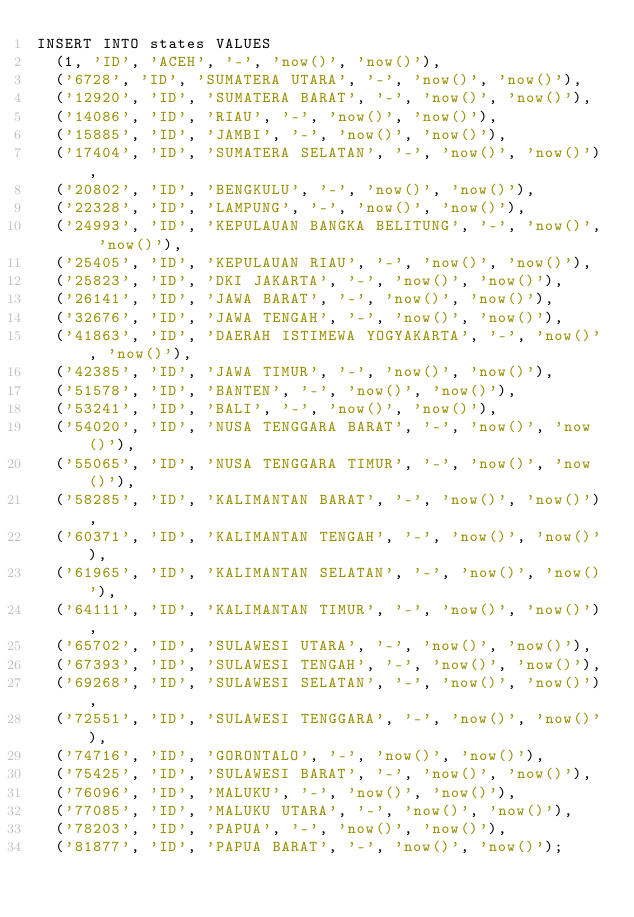Convert code to text. <code><loc_0><loc_0><loc_500><loc_500><_SQL_>INSERT INTO states VALUES
  (1, 'ID', 'ACEH', '-', 'now()', 'now()'),
  ('6728', 'ID', 'SUMATERA UTARA', '-', 'now()', 'now()'),
  ('12920', 'ID', 'SUMATERA BARAT', '-', 'now()', 'now()'),
  ('14086', 'ID', 'RIAU', '-', 'now()', 'now()'),
  ('15885', 'ID', 'JAMBI', '-', 'now()', 'now()'),
  ('17404', 'ID', 'SUMATERA SELATAN', '-', 'now()', 'now()'),
  ('20802', 'ID', 'BENGKULU', '-', 'now()', 'now()'),
  ('22328', 'ID', 'LAMPUNG', '-', 'now()', 'now()'),
  ('24993', 'ID', 'KEPULAUAN BANGKA BELITUNG', '-', 'now()', 'now()'),
  ('25405', 'ID', 'KEPULAUAN RIAU', '-', 'now()', 'now()'),
  ('25823', 'ID', 'DKI JAKARTA', '-', 'now()', 'now()'),
  ('26141', 'ID', 'JAWA BARAT', '-', 'now()', 'now()'),
  ('32676', 'ID', 'JAWA TENGAH', '-', 'now()', 'now()'),
  ('41863', 'ID', 'DAERAH ISTIMEWA YOGYAKARTA', '-', 'now()', 'now()'),
  ('42385', 'ID', 'JAWA TIMUR', '-', 'now()', 'now()'),
  ('51578', 'ID', 'BANTEN', '-', 'now()', 'now()'),
  ('53241', 'ID', 'BALI', '-', 'now()', 'now()'),
  ('54020', 'ID', 'NUSA TENGGARA BARAT', '-', 'now()', 'now()'),
  ('55065', 'ID', 'NUSA TENGGARA TIMUR', '-', 'now()', 'now()'),
  ('58285', 'ID', 'KALIMANTAN BARAT', '-', 'now()', 'now()'),
  ('60371', 'ID', 'KALIMANTAN TENGAH', '-', 'now()', 'now()'),
  ('61965', 'ID', 'KALIMANTAN SELATAN', '-', 'now()', 'now()'),
  ('64111', 'ID', 'KALIMANTAN TIMUR', '-', 'now()', 'now()'),
  ('65702', 'ID', 'SULAWESI UTARA', '-', 'now()', 'now()'),
  ('67393', 'ID', 'SULAWESI TENGAH', '-', 'now()', 'now()'),
  ('69268', 'ID', 'SULAWESI SELATAN', '-', 'now()', 'now()'),
  ('72551', 'ID', 'SULAWESI TENGGARA', '-', 'now()', 'now()'),
  ('74716', 'ID', 'GORONTALO', '-', 'now()', 'now()'),
  ('75425', 'ID', 'SULAWESI BARAT', '-', 'now()', 'now()'),
  ('76096', 'ID', 'MALUKU', '-', 'now()', 'now()'),
  ('77085', 'ID', 'MALUKU UTARA', '-', 'now()', 'now()'),
  ('78203', 'ID', 'PAPUA', '-', 'now()', 'now()'),
  ('81877', 'ID', 'PAPUA BARAT', '-', 'now()', 'now()');
</code> 